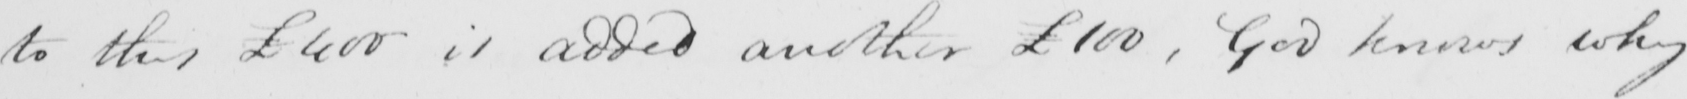Can you tell me what this handwritten text says? to this £400 is added another £100 , God knows why 